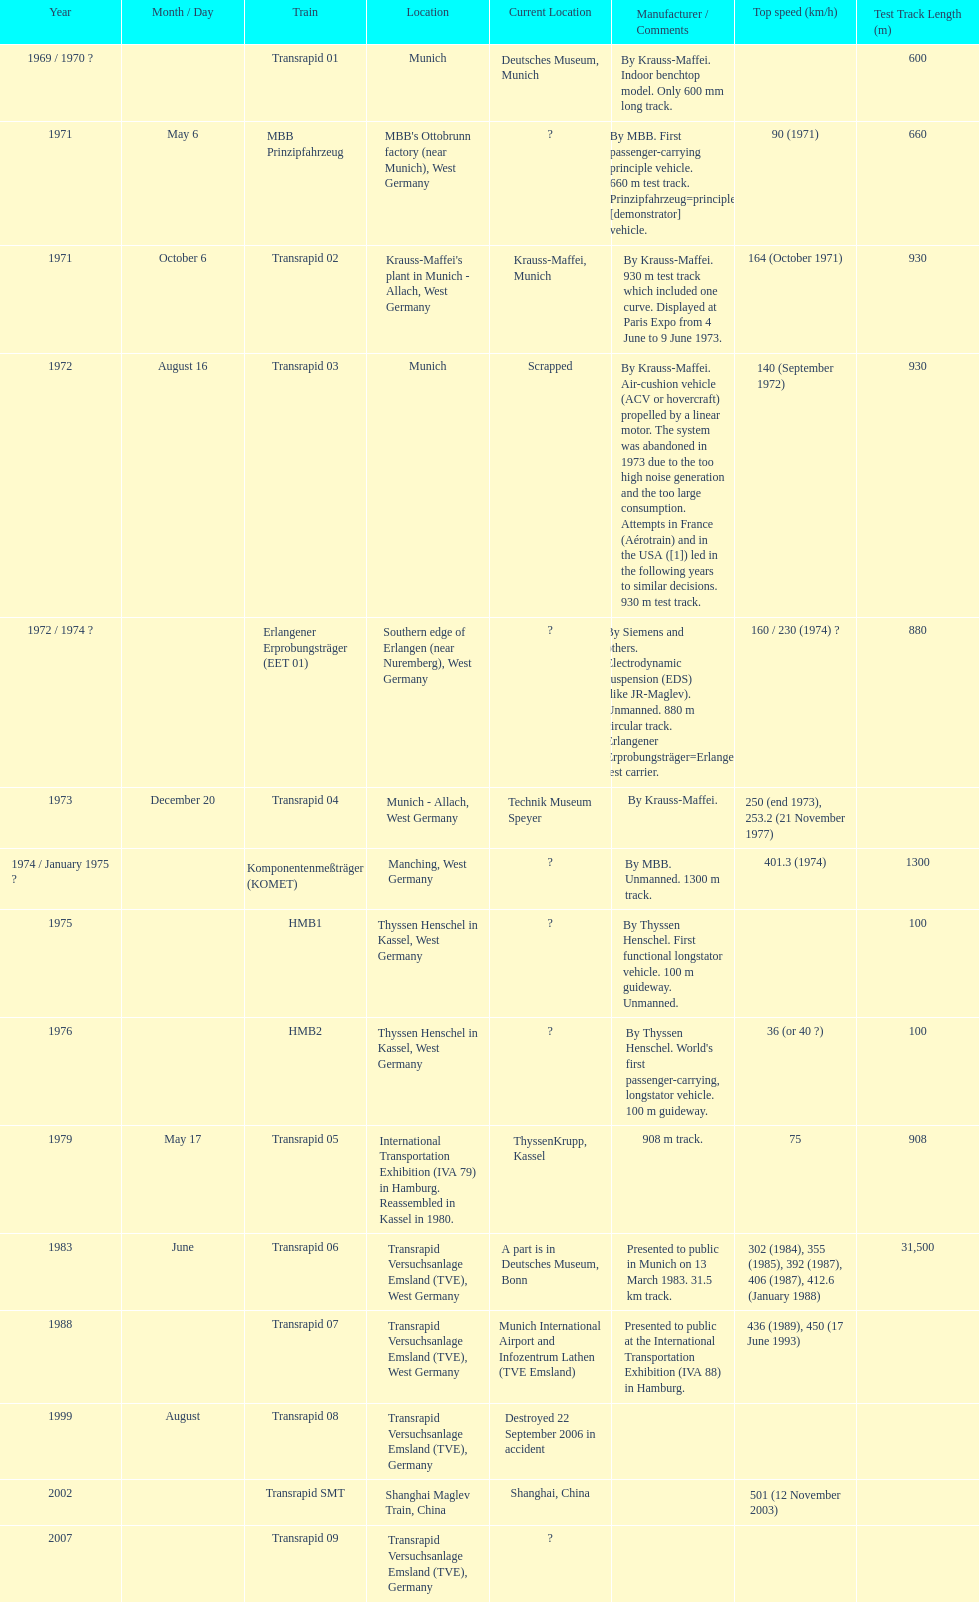How many trains other than the transrapid 07 can go faster than 450km/h? 1. 